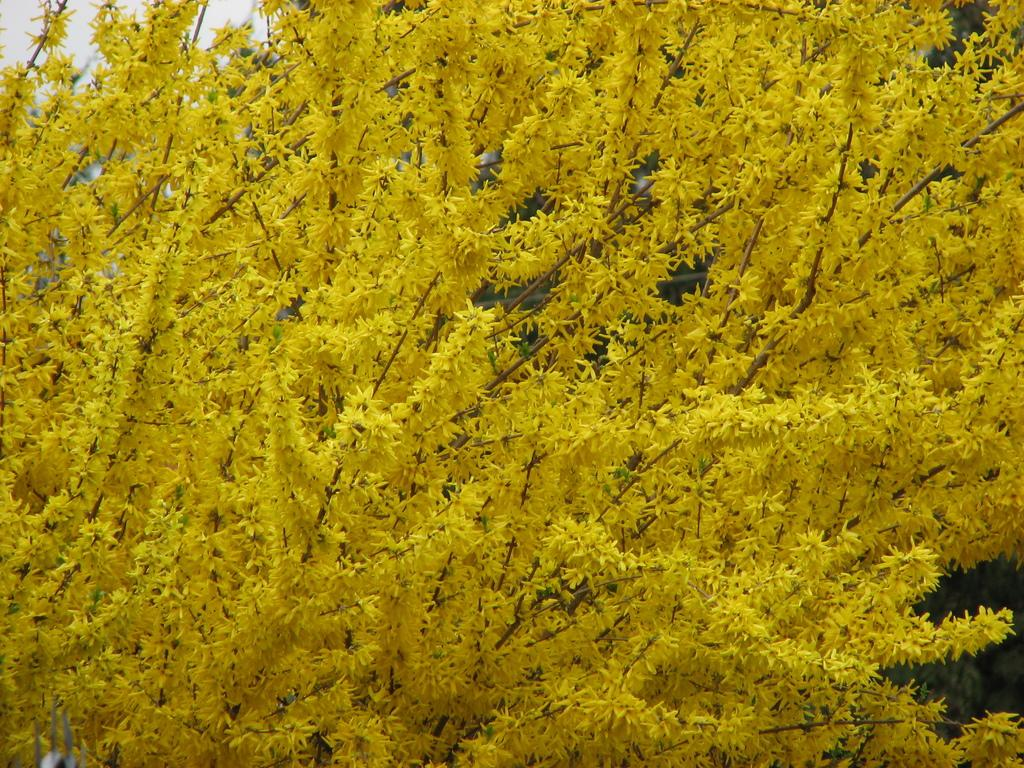What type of vegetation can be seen in the image? There are trees in the image. What part of the natural environment is visible in the image? The sky is visible in the background of the image. What type of answer can be seen in the image? There is no answer present in the image; it features trees and the sky. Is there an airplane flying in the image? There is no airplane visible in the image. 